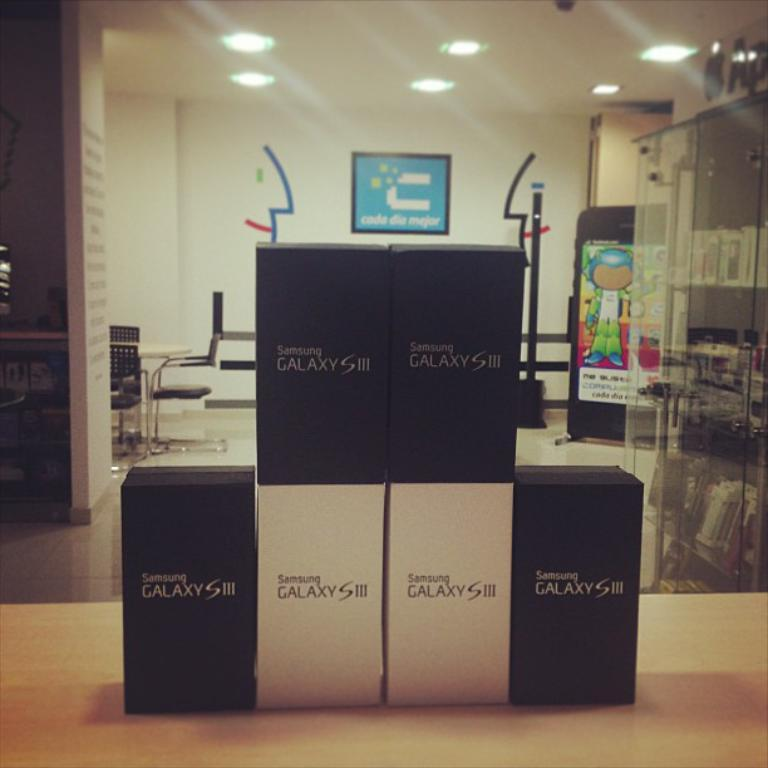<image>
Describe the image concisely. Stacked boxes with Samsung Galaxy SIII printed on the sides of them. 